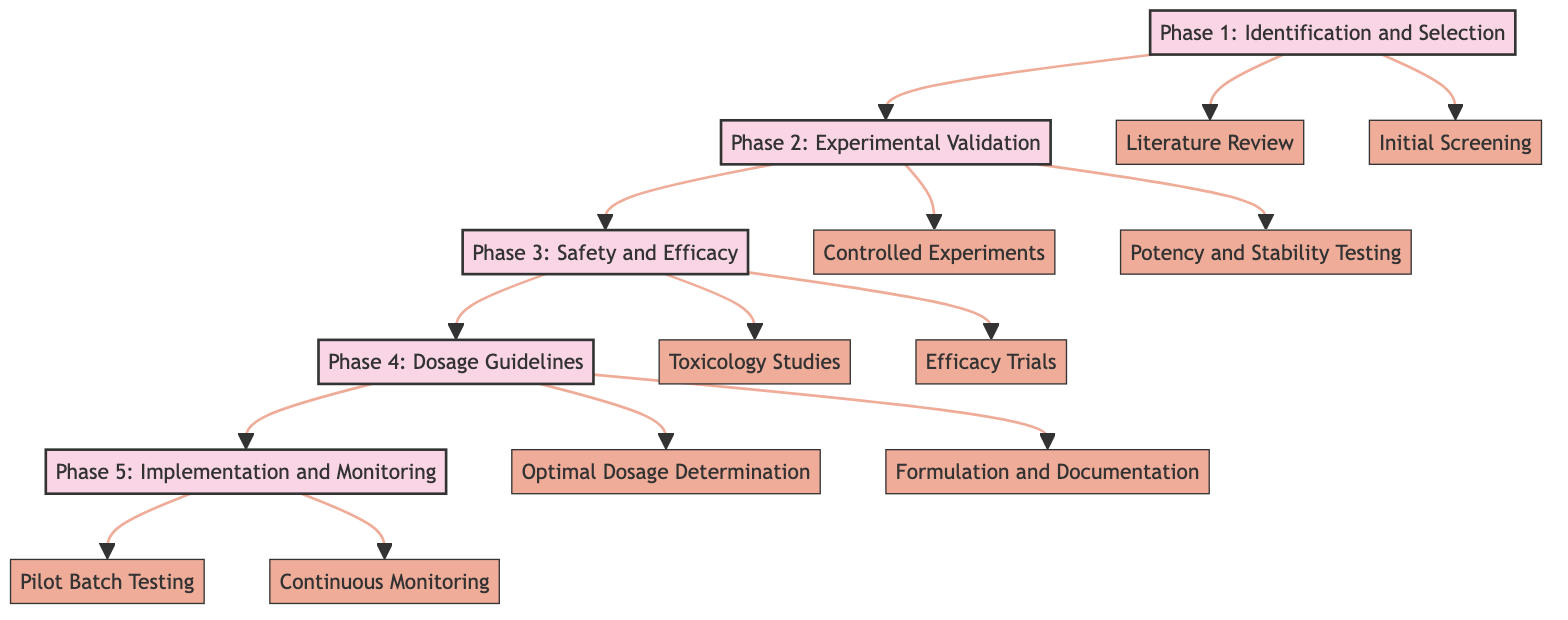What is the first step in Phase 1? The diagram indicates that the first step in Phase 1 is "Literature Review." This can be found by following the flow from Phase 1 down to its first step node.
Answer: Literature Review How many phases are in the clinical pathway? The diagram outlines a total of five distinct phases, from Phase 1 to Phase 5. This is identified by counting the labeled phases at the top of each phase node.
Answer: 5 What is the title of Phase 3? By observing Phase 3 in the diagram, it is specified as "Safety and Efficacy." This title is directly connected at the top of the phase box.
Answer: Safety and Efficacy What dosage range is recommended for ginger in Phase 4? In Phase 4, the optimal dosage for ginger is indicated as "0.5-2%." This can be deduced from the specific information provided under the optimal dosage determination step.
Answer: 0.5-2% Which phase follows "Pilot Batch Testing"? According to the diagram’s flow, "Pilot Batch Testing" is a step within Phase 5, which is followed by the step "Continuous Monitoring." Tracing the flow of Phase 5 confirms this relationship.
Answer: Continuous Monitoring What does the second step in Phase 2 focus on? The second step in Phase 2 is "Potency and Stability Testing." This is determined by looking at the step nodes under Phase 2.
Answer: Potency and Stability Testing What type of studies are performed in Phase 3? Phase 3 includes "Toxicology Studies" and "Efficacy Trials," indicating a focus on safety and efficacy testing. Thus, the studies performed are of these types.
Answer: Toxicology Studies and Efficacy Trials What is the relationship between Phase 2 and Phase 3? The relationship between Phase 2 and Phase 3 is sequential; after completing the steps in Phase 2 (Experimental Validation), one proceeds to Phase 3 (Safety and Efficacy) as indicated by the arrow flow.
Answer: Sequential How many steps are there in Phase 4? Phase 4 consists of two steps: "Optimal Dosage Determination" and "Formulation and Documentation." This can be verified by counting the step nodes under Phase 4.
Answer: 2 